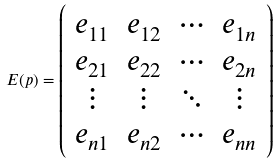<formula> <loc_0><loc_0><loc_500><loc_500>E ( p ) = \left ( \begin{array} { c c c c } e _ { 1 1 } & e _ { 1 2 } & \cdots & e _ { 1 n } \\ e _ { 2 1 } & e _ { 2 2 } & \cdots & e _ { 2 n } \\ \vdots & \vdots & \ddots & \vdots \\ e _ { n 1 } & e _ { n 2 } & \cdots & e _ { n n } \\ \end{array} \right )</formula> 